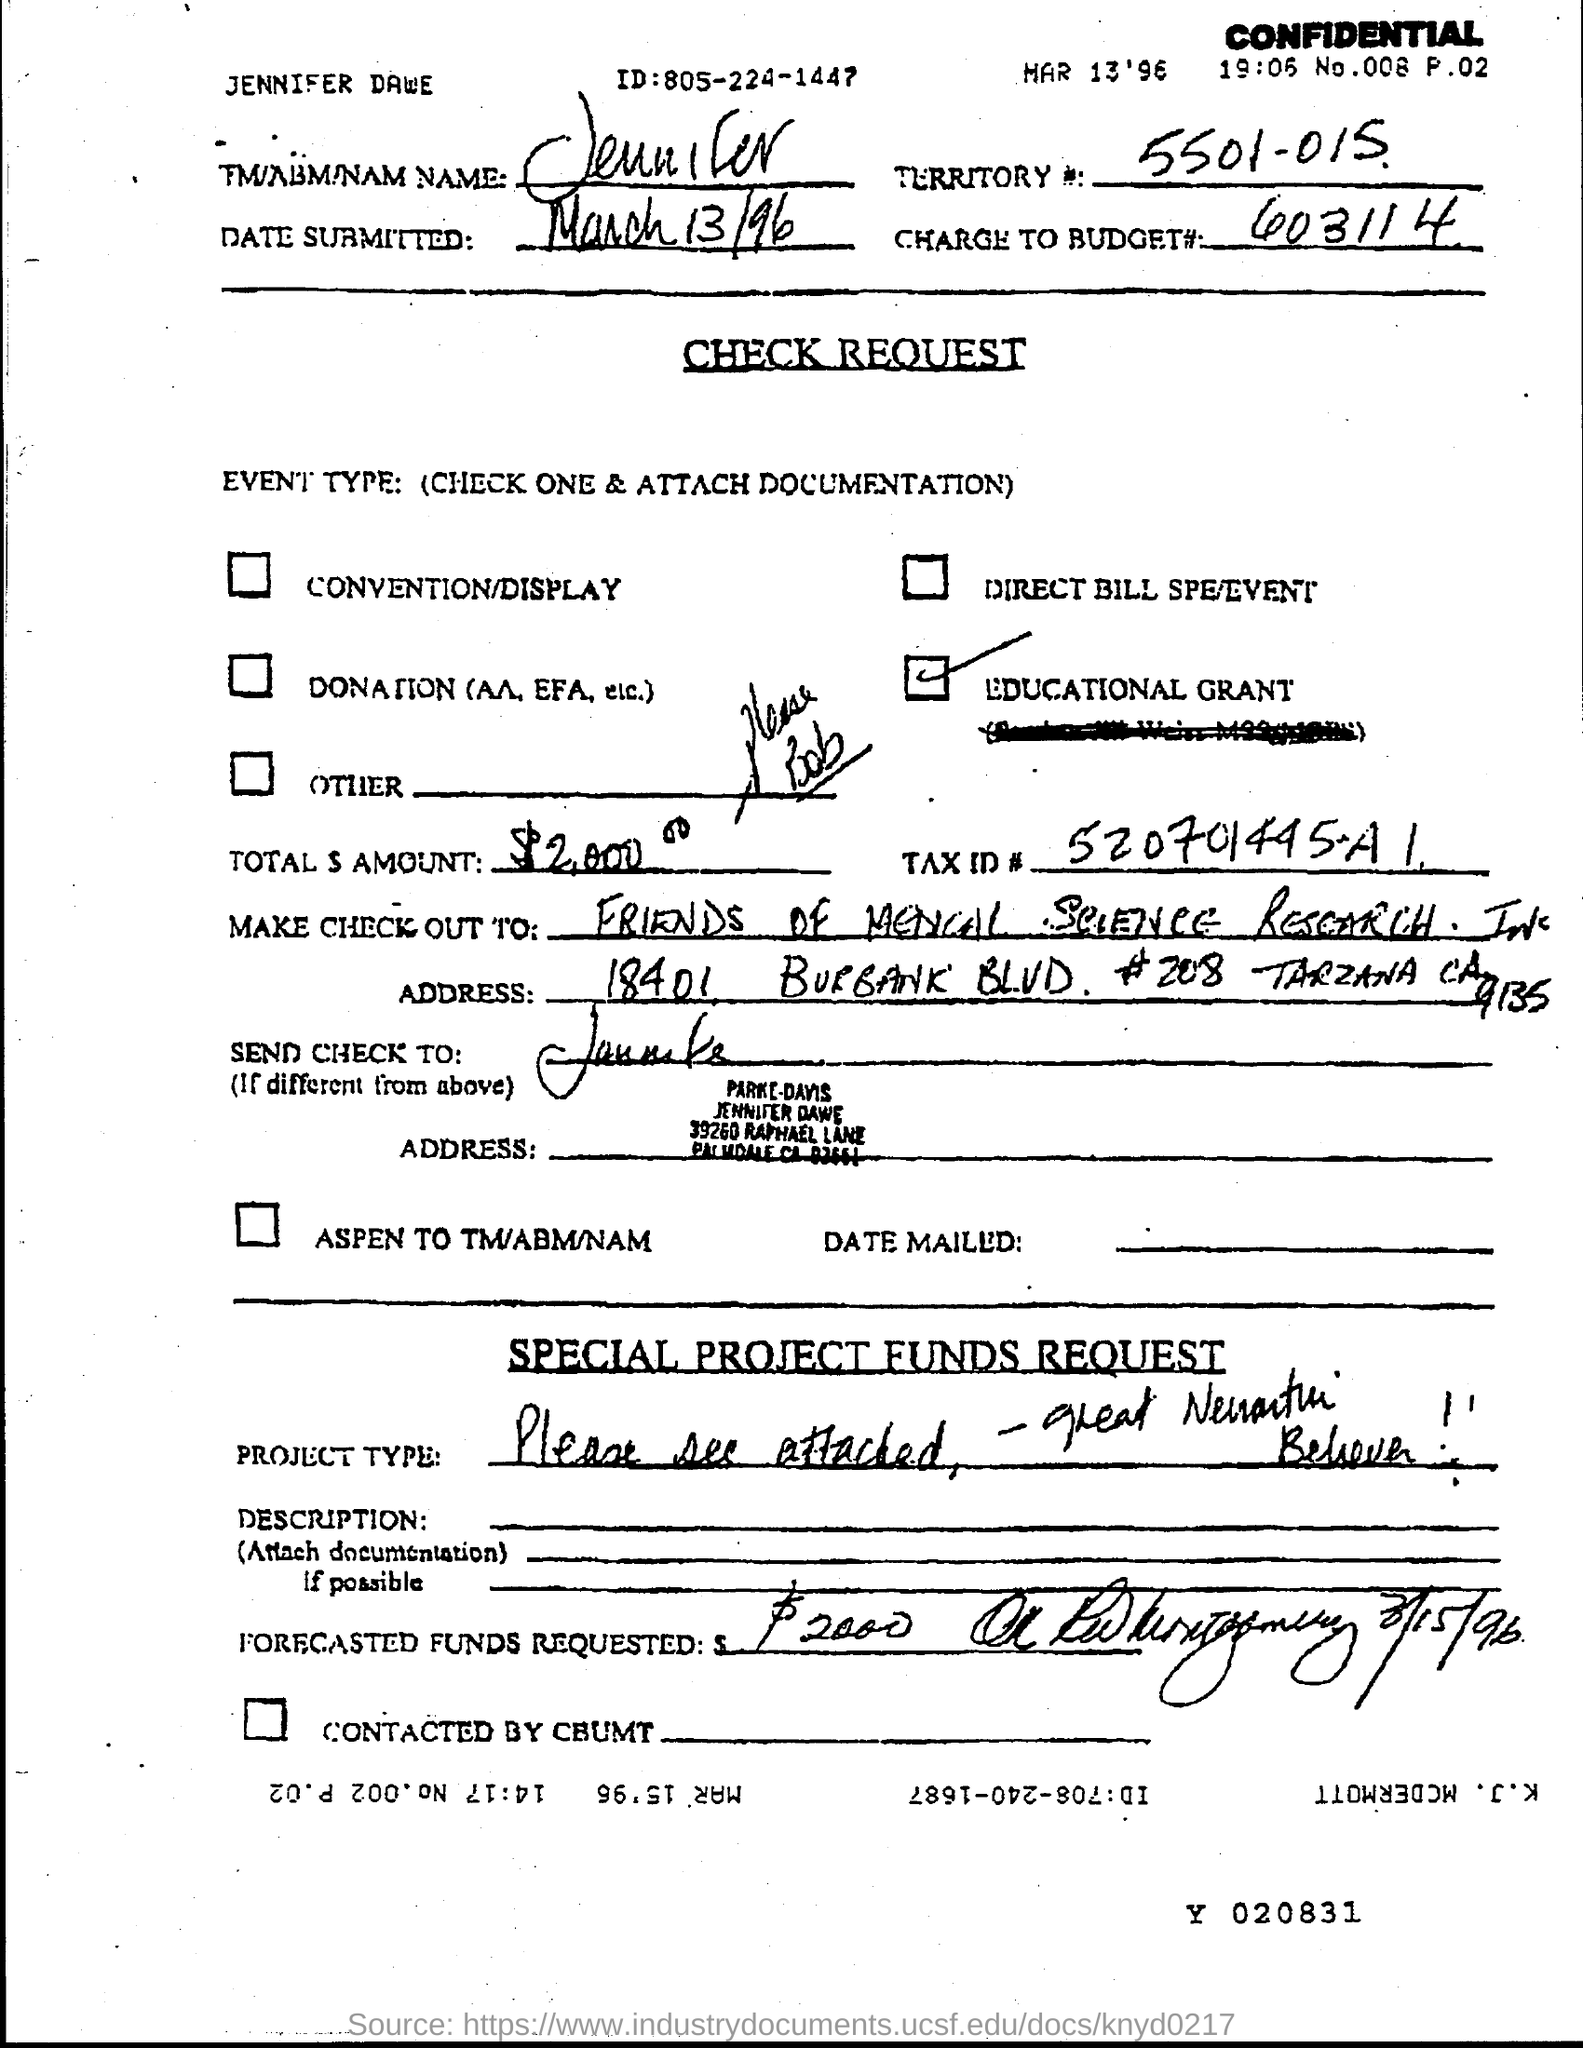What is the id?
Offer a very short reply. 805-224-1447. What is the charge to budget #?
Your response must be concise. 603114. What is the territory #?
Keep it short and to the point. 5501-015. What is the tax id #?
Offer a terse response. 520701445-A1. 